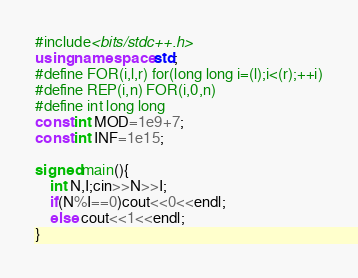Convert code to text. <code><loc_0><loc_0><loc_500><loc_500><_C++_>#include<bits/stdc++.h>
using namespace std;
#define FOR(i,l,r) for(long long i=(l);i<(r);++i)
#define REP(i,n) FOR(i,0,n)
#define int long long
const int MOD=1e9+7;
const int INF=1e15;

signed main(){
    int N,I;cin>>N>>I;
    if(N%I==0)cout<<0<<endl;
    else cout<<1<<endl;
}</code> 